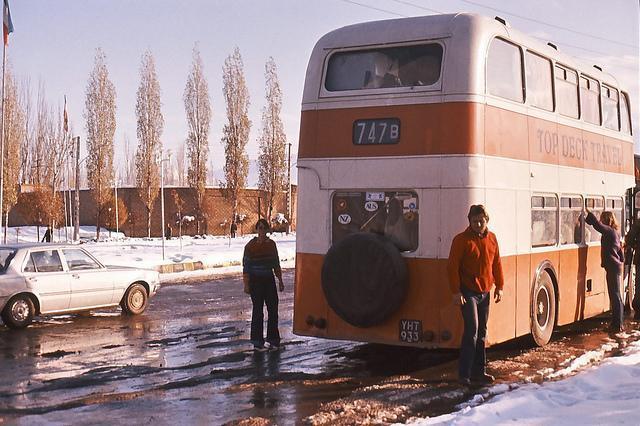How many people are in the photo?
Give a very brief answer. 3. How many birds are flying around?
Give a very brief answer. 0. 